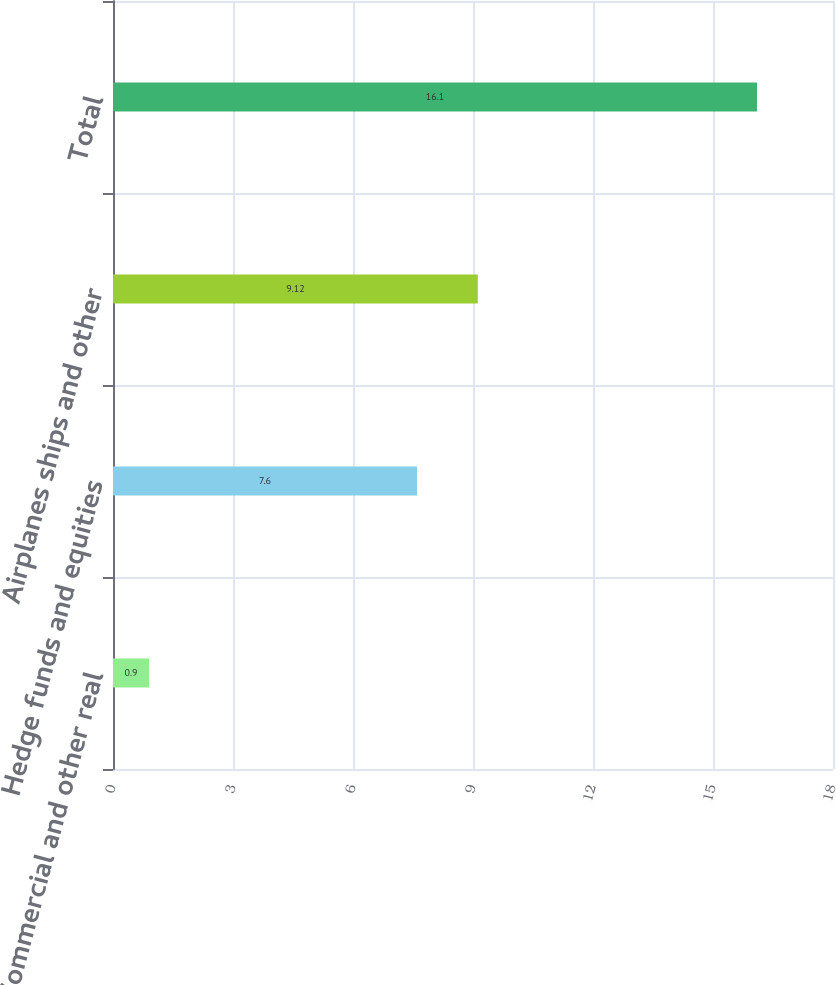<chart> <loc_0><loc_0><loc_500><loc_500><bar_chart><fcel>Commercial and other real<fcel>Hedge funds and equities<fcel>Airplanes ships and other<fcel>Total<nl><fcel>0.9<fcel>7.6<fcel>9.12<fcel>16.1<nl></chart> 